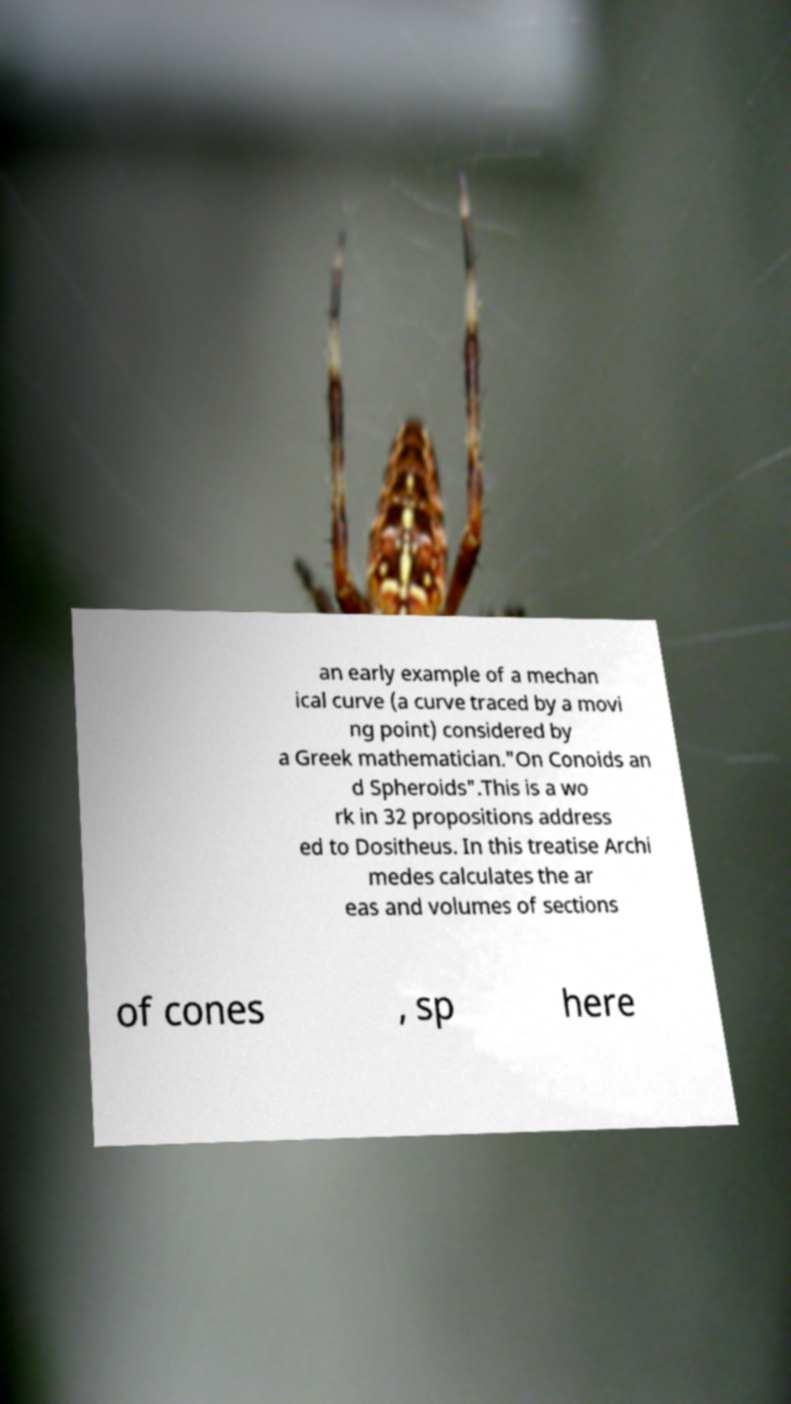What messages or text are displayed in this image? I need them in a readable, typed format. an early example of a mechan ical curve (a curve traced by a movi ng point) considered by a Greek mathematician."On Conoids an d Spheroids".This is a wo rk in 32 propositions address ed to Dositheus. In this treatise Archi medes calculates the ar eas and volumes of sections of cones , sp here 